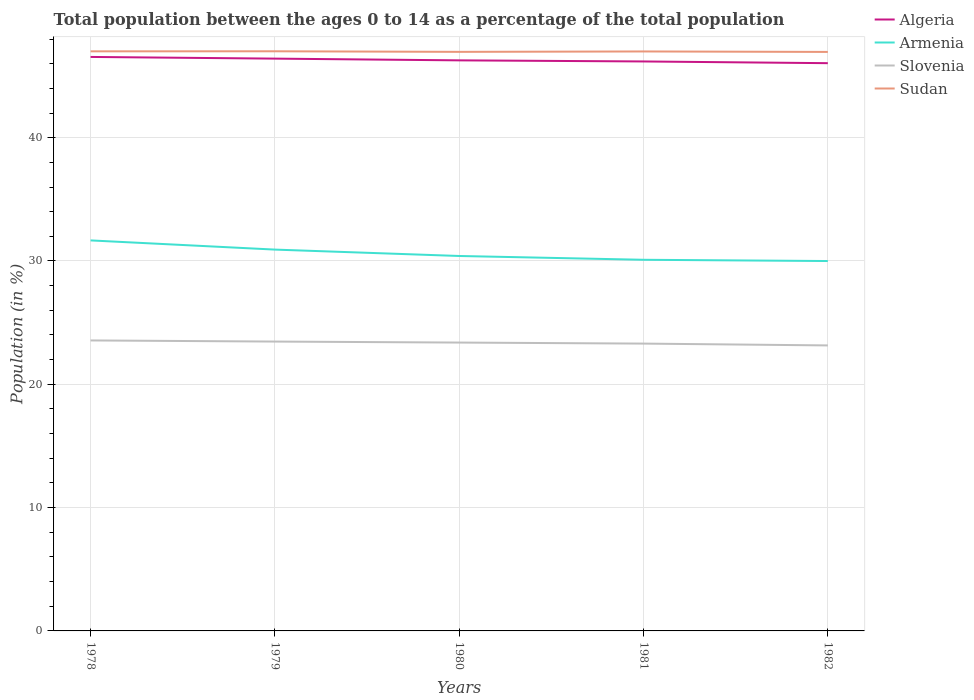How many different coloured lines are there?
Your response must be concise. 4. Across all years, what is the maximum percentage of the population ages 0 to 14 in Sudan?
Your answer should be very brief. 46.96. In which year was the percentage of the population ages 0 to 14 in Armenia maximum?
Offer a terse response. 1982. What is the total percentage of the population ages 0 to 14 in Sudan in the graph?
Offer a terse response. 0.01. What is the difference between the highest and the second highest percentage of the population ages 0 to 14 in Algeria?
Provide a succinct answer. 0.51. What is the difference between the highest and the lowest percentage of the population ages 0 to 14 in Algeria?
Your response must be concise. 2. How many lines are there?
Offer a terse response. 4. How many years are there in the graph?
Ensure brevity in your answer.  5. Are the values on the major ticks of Y-axis written in scientific E-notation?
Your response must be concise. No. Where does the legend appear in the graph?
Make the answer very short. Top right. What is the title of the graph?
Ensure brevity in your answer.  Total population between the ages 0 to 14 as a percentage of the total population. What is the label or title of the X-axis?
Provide a succinct answer. Years. What is the Population (in %) of Algeria in 1978?
Your answer should be compact. 46.55. What is the Population (in %) in Armenia in 1978?
Keep it short and to the point. 31.67. What is the Population (in %) in Slovenia in 1978?
Provide a succinct answer. 23.56. What is the Population (in %) in Sudan in 1978?
Your answer should be very brief. 47. What is the Population (in %) of Algeria in 1979?
Offer a very short reply. 46.41. What is the Population (in %) of Armenia in 1979?
Provide a short and direct response. 30.93. What is the Population (in %) of Slovenia in 1979?
Make the answer very short. 23.47. What is the Population (in %) of Sudan in 1979?
Make the answer very short. 47.01. What is the Population (in %) of Algeria in 1980?
Offer a terse response. 46.27. What is the Population (in %) in Armenia in 1980?
Keep it short and to the point. 30.41. What is the Population (in %) of Slovenia in 1980?
Your answer should be very brief. 23.39. What is the Population (in %) of Sudan in 1980?
Offer a terse response. 46.96. What is the Population (in %) of Algeria in 1981?
Keep it short and to the point. 46.18. What is the Population (in %) of Armenia in 1981?
Provide a short and direct response. 30.1. What is the Population (in %) of Slovenia in 1981?
Your answer should be very brief. 23.3. What is the Population (in %) in Sudan in 1981?
Ensure brevity in your answer.  46.99. What is the Population (in %) in Algeria in 1982?
Ensure brevity in your answer.  46.04. What is the Population (in %) of Armenia in 1982?
Give a very brief answer. 30. What is the Population (in %) of Slovenia in 1982?
Your answer should be very brief. 23.15. What is the Population (in %) in Sudan in 1982?
Keep it short and to the point. 46.96. Across all years, what is the maximum Population (in %) in Algeria?
Keep it short and to the point. 46.55. Across all years, what is the maximum Population (in %) in Armenia?
Give a very brief answer. 31.67. Across all years, what is the maximum Population (in %) of Slovenia?
Your answer should be very brief. 23.56. Across all years, what is the maximum Population (in %) of Sudan?
Provide a short and direct response. 47.01. Across all years, what is the minimum Population (in %) in Algeria?
Your answer should be very brief. 46.04. Across all years, what is the minimum Population (in %) in Armenia?
Provide a succinct answer. 30. Across all years, what is the minimum Population (in %) of Slovenia?
Provide a succinct answer. 23.15. Across all years, what is the minimum Population (in %) in Sudan?
Offer a terse response. 46.96. What is the total Population (in %) in Algeria in the graph?
Ensure brevity in your answer.  231.46. What is the total Population (in %) of Armenia in the graph?
Offer a terse response. 153.1. What is the total Population (in %) in Slovenia in the graph?
Offer a terse response. 116.86. What is the total Population (in %) in Sudan in the graph?
Provide a short and direct response. 234.92. What is the difference between the Population (in %) of Algeria in 1978 and that in 1979?
Make the answer very short. 0.14. What is the difference between the Population (in %) of Armenia in 1978 and that in 1979?
Make the answer very short. 0.74. What is the difference between the Population (in %) in Slovenia in 1978 and that in 1979?
Your answer should be very brief. 0.09. What is the difference between the Population (in %) in Sudan in 1978 and that in 1979?
Your answer should be very brief. -0. What is the difference between the Population (in %) in Algeria in 1978 and that in 1980?
Provide a short and direct response. 0.28. What is the difference between the Population (in %) of Armenia in 1978 and that in 1980?
Provide a short and direct response. 1.26. What is the difference between the Population (in %) of Slovenia in 1978 and that in 1980?
Ensure brevity in your answer.  0.17. What is the difference between the Population (in %) of Sudan in 1978 and that in 1980?
Your answer should be compact. 0.04. What is the difference between the Population (in %) of Algeria in 1978 and that in 1981?
Give a very brief answer. 0.37. What is the difference between the Population (in %) of Armenia in 1978 and that in 1981?
Provide a short and direct response. 1.57. What is the difference between the Population (in %) of Slovenia in 1978 and that in 1981?
Give a very brief answer. 0.26. What is the difference between the Population (in %) of Sudan in 1978 and that in 1981?
Give a very brief answer. 0.01. What is the difference between the Population (in %) of Algeria in 1978 and that in 1982?
Offer a very short reply. 0.51. What is the difference between the Population (in %) in Armenia in 1978 and that in 1982?
Give a very brief answer. 1.67. What is the difference between the Population (in %) of Slovenia in 1978 and that in 1982?
Your answer should be compact. 0.4. What is the difference between the Population (in %) of Sudan in 1978 and that in 1982?
Ensure brevity in your answer.  0.05. What is the difference between the Population (in %) in Algeria in 1979 and that in 1980?
Ensure brevity in your answer.  0.14. What is the difference between the Population (in %) of Armenia in 1979 and that in 1980?
Offer a very short reply. 0.52. What is the difference between the Population (in %) of Slovenia in 1979 and that in 1980?
Offer a terse response. 0.08. What is the difference between the Population (in %) in Sudan in 1979 and that in 1980?
Your answer should be compact. 0.05. What is the difference between the Population (in %) of Algeria in 1979 and that in 1981?
Provide a succinct answer. 0.23. What is the difference between the Population (in %) in Armenia in 1979 and that in 1981?
Your answer should be compact. 0.83. What is the difference between the Population (in %) of Slovenia in 1979 and that in 1981?
Your answer should be compact. 0.16. What is the difference between the Population (in %) of Sudan in 1979 and that in 1981?
Your answer should be compact. 0.01. What is the difference between the Population (in %) in Algeria in 1979 and that in 1982?
Offer a very short reply. 0.37. What is the difference between the Population (in %) of Armenia in 1979 and that in 1982?
Ensure brevity in your answer.  0.93. What is the difference between the Population (in %) of Slovenia in 1979 and that in 1982?
Offer a very short reply. 0.31. What is the difference between the Population (in %) in Sudan in 1979 and that in 1982?
Give a very brief answer. 0.05. What is the difference between the Population (in %) in Algeria in 1980 and that in 1981?
Offer a very short reply. 0.09. What is the difference between the Population (in %) in Armenia in 1980 and that in 1981?
Offer a very short reply. 0.31. What is the difference between the Population (in %) in Slovenia in 1980 and that in 1981?
Make the answer very short. 0.08. What is the difference between the Population (in %) in Sudan in 1980 and that in 1981?
Provide a succinct answer. -0.03. What is the difference between the Population (in %) in Algeria in 1980 and that in 1982?
Your answer should be compact. 0.23. What is the difference between the Population (in %) of Armenia in 1980 and that in 1982?
Provide a succinct answer. 0.41. What is the difference between the Population (in %) of Slovenia in 1980 and that in 1982?
Ensure brevity in your answer.  0.23. What is the difference between the Population (in %) of Sudan in 1980 and that in 1982?
Provide a succinct answer. 0. What is the difference between the Population (in %) of Algeria in 1981 and that in 1982?
Your answer should be compact. 0.14. What is the difference between the Population (in %) of Armenia in 1981 and that in 1982?
Provide a short and direct response. 0.1. What is the difference between the Population (in %) of Slovenia in 1981 and that in 1982?
Your response must be concise. 0.15. What is the difference between the Population (in %) in Sudan in 1981 and that in 1982?
Offer a very short reply. 0.04. What is the difference between the Population (in %) of Algeria in 1978 and the Population (in %) of Armenia in 1979?
Make the answer very short. 15.62. What is the difference between the Population (in %) in Algeria in 1978 and the Population (in %) in Slovenia in 1979?
Provide a succinct answer. 23.08. What is the difference between the Population (in %) of Algeria in 1978 and the Population (in %) of Sudan in 1979?
Offer a terse response. -0.46. What is the difference between the Population (in %) in Armenia in 1978 and the Population (in %) in Slovenia in 1979?
Your answer should be compact. 8.2. What is the difference between the Population (in %) in Armenia in 1978 and the Population (in %) in Sudan in 1979?
Your answer should be very brief. -15.34. What is the difference between the Population (in %) of Slovenia in 1978 and the Population (in %) of Sudan in 1979?
Keep it short and to the point. -23.45. What is the difference between the Population (in %) of Algeria in 1978 and the Population (in %) of Armenia in 1980?
Keep it short and to the point. 16.14. What is the difference between the Population (in %) in Algeria in 1978 and the Population (in %) in Slovenia in 1980?
Offer a terse response. 23.16. What is the difference between the Population (in %) of Algeria in 1978 and the Population (in %) of Sudan in 1980?
Offer a very short reply. -0.41. What is the difference between the Population (in %) in Armenia in 1978 and the Population (in %) in Slovenia in 1980?
Give a very brief answer. 8.29. What is the difference between the Population (in %) in Armenia in 1978 and the Population (in %) in Sudan in 1980?
Make the answer very short. -15.29. What is the difference between the Population (in %) in Slovenia in 1978 and the Population (in %) in Sudan in 1980?
Offer a very short reply. -23.4. What is the difference between the Population (in %) of Algeria in 1978 and the Population (in %) of Armenia in 1981?
Your response must be concise. 16.45. What is the difference between the Population (in %) of Algeria in 1978 and the Population (in %) of Slovenia in 1981?
Make the answer very short. 23.25. What is the difference between the Population (in %) in Algeria in 1978 and the Population (in %) in Sudan in 1981?
Give a very brief answer. -0.44. What is the difference between the Population (in %) in Armenia in 1978 and the Population (in %) in Slovenia in 1981?
Make the answer very short. 8.37. What is the difference between the Population (in %) in Armenia in 1978 and the Population (in %) in Sudan in 1981?
Keep it short and to the point. -15.32. What is the difference between the Population (in %) in Slovenia in 1978 and the Population (in %) in Sudan in 1981?
Offer a very short reply. -23.44. What is the difference between the Population (in %) of Algeria in 1978 and the Population (in %) of Armenia in 1982?
Your response must be concise. 16.55. What is the difference between the Population (in %) in Algeria in 1978 and the Population (in %) in Slovenia in 1982?
Provide a short and direct response. 23.4. What is the difference between the Population (in %) of Algeria in 1978 and the Population (in %) of Sudan in 1982?
Ensure brevity in your answer.  -0.41. What is the difference between the Population (in %) in Armenia in 1978 and the Population (in %) in Slovenia in 1982?
Give a very brief answer. 8.52. What is the difference between the Population (in %) of Armenia in 1978 and the Population (in %) of Sudan in 1982?
Your answer should be compact. -15.29. What is the difference between the Population (in %) in Slovenia in 1978 and the Population (in %) in Sudan in 1982?
Your response must be concise. -23.4. What is the difference between the Population (in %) in Algeria in 1979 and the Population (in %) in Armenia in 1980?
Ensure brevity in your answer.  16.01. What is the difference between the Population (in %) of Algeria in 1979 and the Population (in %) of Slovenia in 1980?
Provide a succinct answer. 23.03. What is the difference between the Population (in %) in Algeria in 1979 and the Population (in %) in Sudan in 1980?
Offer a terse response. -0.55. What is the difference between the Population (in %) of Armenia in 1979 and the Population (in %) of Slovenia in 1980?
Offer a very short reply. 7.54. What is the difference between the Population (in %) of Armenia in 1979 and the Population (in %) of Sudan in 1980?
Ensure brevity in your answer.  -16.04. What is the difference between the Population (in %) in Slovenia in 1979 and the Population (in %) in Sudan in 1980?
Give a very brief answer. -23.5. What is the difference between the Population (in %) of Algeria in 1979 and the Population (in %) of Armenia in 1981?
Your answer should be very brief. 16.31. What is the difference between the Population (in %) of Algeria in 1979 and the Population (in %) of Slovenia in 1981?
Keep it short and to the point. 23.11. What is the difference between the Population (in %) of Algeria in 1979 and the Population (in %) of Sudan in 1981?
Your response must be concise. -0.58. What is the difference between the Population (in %) of Armenia in 1979 and the Population (in %) of Slovenia in 1981?
Provide a succinct answer. 7.62. What is the difference between the Population (in %) of Armenia in 1979 and the Population (in %) of Sudan in 1981?
Make the answer very short. -16.07. What is the difference between the Population (in %) in Slovenia in 1979 and the Population (in %) in Sudan in 1981?
Give a very brief answer. -23.53. What is the difference between the Population (in %) in Algeria in 1979 and the Population (in %) in Armenia in 1982?
Provide a succinct answer. 16.41. What is the difference between the Population (in %) in Algeria in 1979 and the Population (in %) in Slovenia in 1982?
Your answer should be very brief. 23.26. What is the difference between the Population (in %) of Algeria in 1979 and the Population (in %) of Sudan in 1982?
Provide a short and direct response. -0.54. What is the difference between the Population (in %) in Armenia in 1979 and the Population (in %) in Slovenia in 1982?
Your answer should be compact. 7.77. What is the difference between the Population (in %) in Armenia in 1979 and the Population (in %) in Sudan in 1982?
Your answer should be very brief. -16.03. What is the difference between the Population (in %) of Slovenia in 1979 and the Population (in %) of Sudan in 1982?
Your answer should be compact. -23.49. What is the difference between the Population (in %) of Algeria in 1980 and the Population (in %) of Armenia in 1981?
Keep it short and to the point. 16.17. What is the difference between the Population (in %) in Algeria in 1980 and the Population (in %) in Slovenia in 1981?
Give a very brief answer. 22.97. What is the difference between the Population (in %) of Algeria in 1980 and the Population (in %) of Sudan in 1981?
Make the answer very short. -0.72. What is the difference between the Population (in %) in Armenia in 1980 and the Population (in %) in Slovenia in 1981?
Make the answer very short. 7.1. What is the difference between the Population (in %) of Armenia in 1980 and the Population (in %) of Sudan in 1981?
Keep it short and to the point. -16.59. What is the difference between the Population (in %) of Slovenia in 1980 and the Population (in %) of Sudan in 1981?
Offer a terse response. -23.61. What is the difference between the Population (in %) in Algeria in 1980 and the Population (in %) in Armenia in 1982?
Provide a short and direct response. 16.27. What is the difference between the Population (in %) of Algeria in 1980 and the Population (in %) of Slovenia in 1982?
Your response must be concise. 23.12. What is the difference between the Population (in %) of Algeria in 1980 and the Population (in %) of Sudan in 1982?
Offer a very short reply. -0.68. What is the difference between the Population (in %) in Armenia in 1980 and the Population (in %) in Slovenia in 1982?
Your answer should be very brief. 7.25. What is the difference between the Population (in %) in Armenia in 1980 and the Population (in %) in Sudan in 1982?
Your answer should be compact. -16.55. What is the difference between the Population (in %) in Slovenia in 1980 and the Population (in %) in Sudan in 1982?
Your answer should be very brief. -23.57. What is the difference between the Population (in %) in Algeria in 1981 and the Population (in %) in Armenia in 1982?
Provide a short and direct response. 16.19. What is the difference between the Population (in %) in Algeria in 1981 and the Population (in %) in Slovenia in 1982?
Your answer should be compact. 23.03. What is the difference between the Population (in %) in Algeria in 1981 and the Population (in %) in Sudan in 1982?
Offer a very short reply. -0.77. What is the difference between the Population (in %) of Armenia in 1981 and the Population (in %) of Slovenia in 1982?
Keep it short and to the point. 6.95. What is the difference between the Population (in %) in Armenia in 1981 and the Population (in %) in Sudan in 1982?
Provide a succinct answer. -16.86. What is the difference between the Population (in %) of Slovenia in 1981 and the Population (in %) of Sudan in 1982?
Keep it short and to the point. -23.65. What is the average Population (in %) in Algeria per year?
Provide a succinct answer. 46.29. What is the average Population (in %) of Armenia per year?
Keep it short and to the point. 30.62. What is the average Population (in %) of Slovenia per year?
Your response must be concise. 23.37. What is the average Population (in %) in Sudan per year?
Your response must be concise. 46.98. In the year 1978, what is the difference between the Population (in %) of Algeria and Population (in %) of Armenia?
Your answer should be very brief. 14.88. In the year 1978, what is the difference between the Population (in %) in Algeria and Population (in %) in Slovenia?
Your answer should be compact. 22.99. In the year 1978, what is the difference between the Population (in %) in Algeria and Population (in %) in Sudan?
Provide a short and direct response. -0.46. In the year 1978, what is the difference between the Population (in %) in Armenia and Population (in %) in Slovenia?
Your answer should be compact. 8.11. In the year 1978, what is the difference between the Population (in %) in Armenia and Population (in %) in Sudan?
Your answer should be compact. -15.33. In the year 1978, what is the difference between the Population (in %) in Slovenia and Population (in %) in Sudan?
Make the answer very short. -23.45. In the year 1979, what is the difference between the Population (in %) in Algeria and Population (in %) in Armenia?
Provide a succinct answer. 15.49. In the year 1979, what is the difference between the Population (in %) in Algeria and Population (in %) in Slovenia?
Your answer should be very brief. 22.95. In the year 1979, what is the difference between the Population (in %) in Algeria and Population (in %) in Sudan?
Offer a terse response. -0.6. In the year 1979, what is the difference between the Population (in %) in Armenia and Population (in %) in Slovenia?
Keep it short and to the point. 7.46. In the year 1979, what is the difference between the Population (in %) in Armenia and Population (in %) in Sudan?
Ensure brevity in your answer.  -16.08. In the year 1979, what is the difference between the Population (in %) in Slovenia and Population (in %) in Sudan?
Your response must be concise. -23.54. In the year 1980, what is the difference between the Population (in %) in Algeria and Population (in %) in Armenia?
Offer a terse response. 15.87. In the year 1980, what is the difference between the Population (in %) in Algeria and Population (in %) in Slovenia?
Give a very brief answer. 22.89. In the year 1980, what is the difference between the Population (in %) of Algeria and Population (in %) of Sudan?
Offer a very short reply. -0.69. In the year 1980, what is the difference between the Population (in %) of Armenia and Population (in %) of Slovenia?
Offer a very short reply. 7.02. In the year 1980, what is the difference between the Population (in %) of Armenia and Population (in %) of Sudan?
Offer a terse response. -16.55. In the year 1980, what is the difference between the Population (in %) in Slovenia and Population (in %) in Sudan?
Provide a succinct answer. -23.58. In the year 1981, what is the difference between the Population (in %) in Algeria and Population (in %) in Armenia?
Your response must be concise. 16.09. In the year 1981, what is the difference between the Population (in %) in Algeria and Population (in %) in Slovenia?
Provide a succinct answer. 22.88. In the year 1981, what is the difference between the Population (in %) of Algeria and Population (in %) of Sudan?
Your response must be concise. -0.81. In the year 1981, what is the difference between the Population (in %) in Armenia and Population (in %) in Slovenia?
Your answer should be compact. 6.8. In the year 1981, what is the difference between the Population (in %) of Armenia and Population (in %) of Sudan?
Provide a short and direct response. -16.9. In the year 1981, what is the difference between the Population (in %) of Slovenia and Population (in %) of Sudan?
Keep it short and to the point. -23.69. In the year 1982, what is the difference between the Population (in %) of Algeria and Population (in %) of Armenia?
Give a very brief answer. 16.05. In the year 1982, what is the difference between the Population (in %) of Algeria and Population (in %) of Slovenia?
Your answer should be very brief. 22.89. In the year 1982, what is the difference between the Population (in %) of Algeria and Population (in %) of Sudan?
Your answer should be very brief. -0.91. In the year 1982, what is the difference between the Population (in %) in Armenia and Population (in %) in Slovenia?
Your answer should be very brief. 6.84. In the year 1982, what is the difference between the Population (in %) in Armenia and Population (in %) in Sudan?
Ensure brevity in your answer.  -16.96. In the year 1982, what is the difference between the Population (in %) in Slovenia and Population (in %) in Sudan?
Offer a very short reply. -23.8. What is the ratio of the Population (in %) in Armenia in 1978 to that in 1979?
Your response must be concise. 1.02. What is the ratio of the Population (in %) of Slovenia in 1978 to that in 1979?
Provide a short and direct response. 1. What is the ratio of the Population (in %) in Sudan in 1978 to that in 1979?
Give a very brief answer. 1. What is the ratio of the Population (in %) in Armenia in 1978 to that in 1980?
Ensure brevity in your answer.  1.04. What is the ratio of the Population (in %) of Slovenia in 1978 to that in 1980?
Provide a short and direct response. 1.01. What is the ratio of the Population (in %) of Algeria in 1978 to that in 1981?
Provide a succinct answer. 1.01. What is the ratio of the Population (in %) of Armenia in 1978 to that in 1981?
Your answer should be very brief. 1.05. What is the ratio of the Population (in %) in Slovenia in 1978 to that in 1981?
Make the answer very short. 1.01. What is the ratio of the Population (in %) in Sudan in 1978 to that in 1981?
Your answer should be very brief. 1. What is the ratio of the Population (in %) in Armenia in 1978 to that in 1982?
Your answer should be compact. 1.06. What is the ratio of the Population (in %) of Slovenia in 1978 to that in 1982?
Ensure brevity in your answer.  1.02. What is the ratio of the Population (in %) in Algeria in 1979 to that in 1980?
Your answer should be compact. 1. What is the ratio of the Population (in %) of Armenia in 1979 to that in 1980?
Make the answer very short. 1.02. What is the ratio of the Population (in %) in Slovenia in 1979 to that in 1980?
Ensure brevity in your answer.  1. What is the ratio of the Population (in %) of Sudan in 1979 to that in 1980?
Give a very brief answer. 1. What is the ratio of the Population (in %) in Armenia in 1979 to that in 1981?
Keep it short and to the point. 1.03. What is the ratio of the Population (in %) in Algeria in 1979 to that in 1982?
Give a very brief answer. 1.01. What is the ratio of the Population (in %) of Armenia in 1979 to that in 1982?
Your answer should be very brief. 1.03. What is the ratio of the Population (in %) in Slovenia in 1979 to that in 1982?
Your response must be concise. 1.01. What is the ratio of the Population (in %) in Algeria in 1980 to that in 1981?
Provide a succinct answer. 1. What is the ratio of the Population (in %) in Armenia in 1980 to that in 1981?
Your response must be concise. 1.01. What is the ratio of the Population (in %) in Slovenia in 1980 to that in 1981?
Offer a very short reply. 1. What is the ratio of the Population (in %) in Sudan in 1980 to that in 1981?
Offer a very short reply. 1. What is the ratio of the Population (in %) in Armenia in 1980 to that in 1982?
Offer a very short reply. 1.01. What is the ratio of the Population (in %) of Algeria in 1981 to that in 1982?
Keep it short and to the point. 1. What is the ratio of the Population (in %) of Armenia in 1981 to that in 1982?
Provide a short and direct response. 1. What is the ratio of the Population (in %) of Slovenia in 1981 to that in 1982?
Provide a succinct answer. 1.01. What is the ratio of the Population (in %) in Sudan in 1981 to that in 1982?
Offer a very short reply. 1. What is the difference between the highest and the second highest Population (in %) of Algeria?
Make the answer very short. 0.14. What is the difference between the highest and the second highest Population (in %) in Armenia?
Provide a succinct answer. 0.74. What is the difference between the highest and the second highest Population (in %) in Slovenia?
Ensure brevity in your answer.  0.09. What is the difference between the highest and the second highest Population (in %) of Sudan?
Provide a short and direct response. 0. What is the difference between the highest and the lowest Population (in %) in Algeria?
Ensure brevity in your answer.  0.51. What is the difference between the highest and the lowest Population (in %) of Armenia?
Make the answer very short. 1.67. What is the difference between the highest and the lowest Population (in %) in Slovenia?
Give a very brief answer. 0.4. What is the difference between the highest and the lowest Population (in %) in Sudan?
Ensure brevity in your answer.  0.05. 